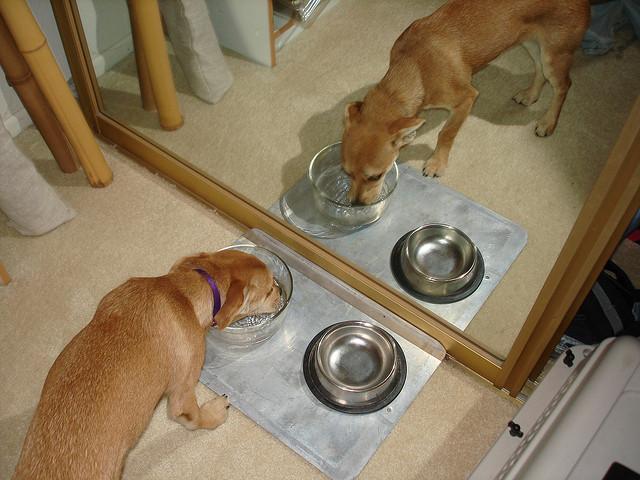How many bowls are there?
Give a very brief answer. 4. How many dogs can you see?
Give a very brief answer. 2. 